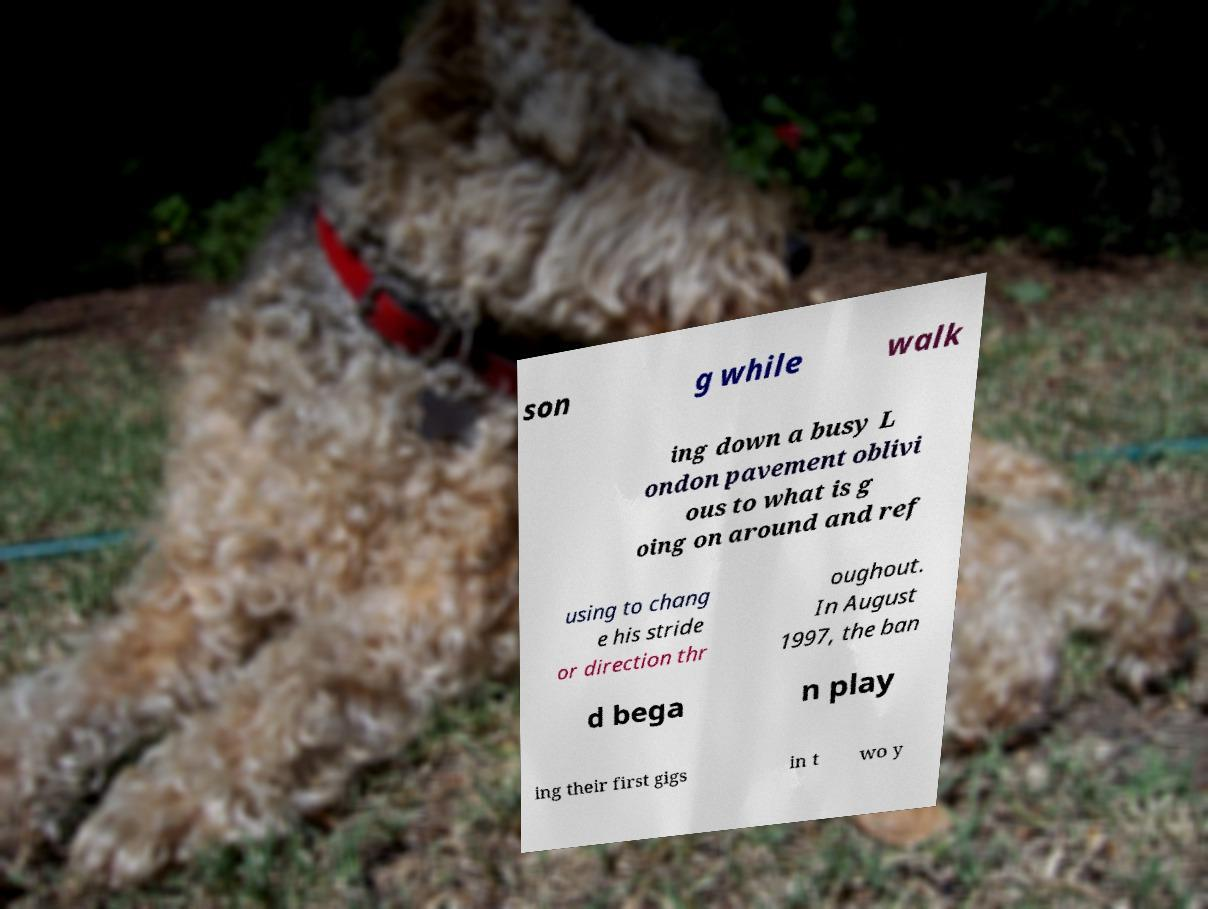What messages or text are displayed in this image? I need them in a readable, typed format. son g while walk ing down a busy L ondon pavement oblivi ous to what is g oing on around and ref using to chang e his stride or direction thr oughout. In August 1997, the ban d bega n play ing their first gigs in t wo y 